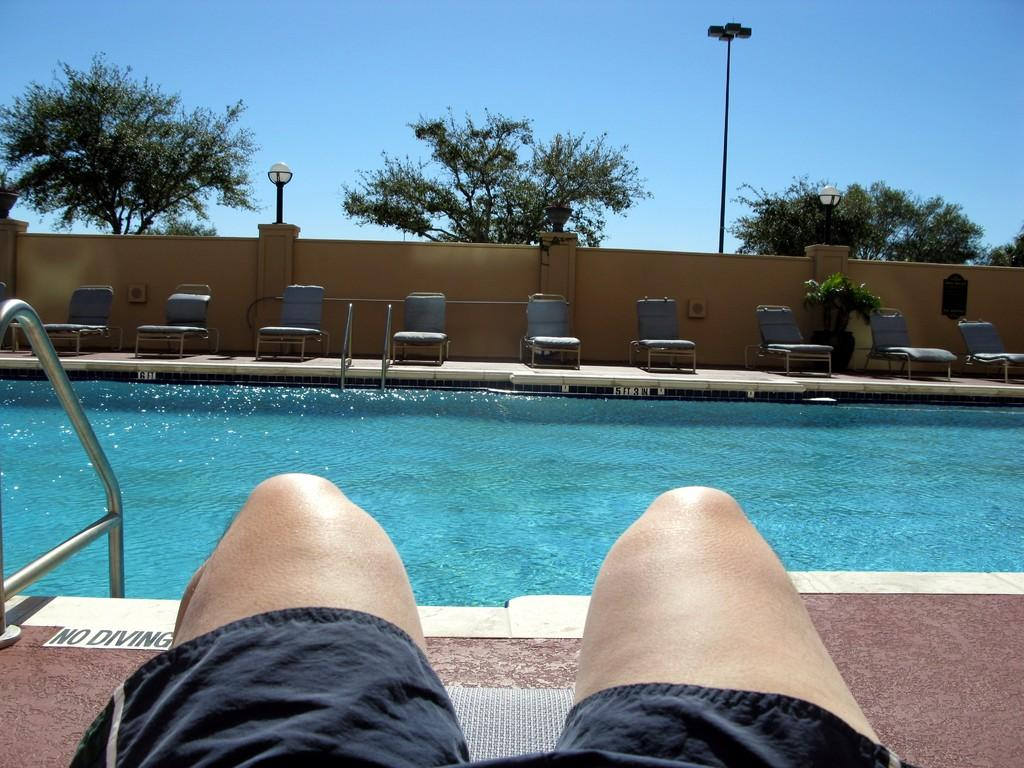What part of a person can be seen in the image? There are legs of a person in the image. What objects are in front of the person? There are metal rods in front of the person. What natural element is visible in the image? There is water visible in the image. What type of furniture is present in the image? There are chairs in the image. What artificial light sources are visible in the image? There are lights in the image. What can be seen in the background of the image? There are trees and a pole in the background of the image. How many hydrants are visible in the image? There are no hydrants present in the image. What type of dance move is the person performing in the image? The image does not show the person performing any dance move; it only shows their legs. 